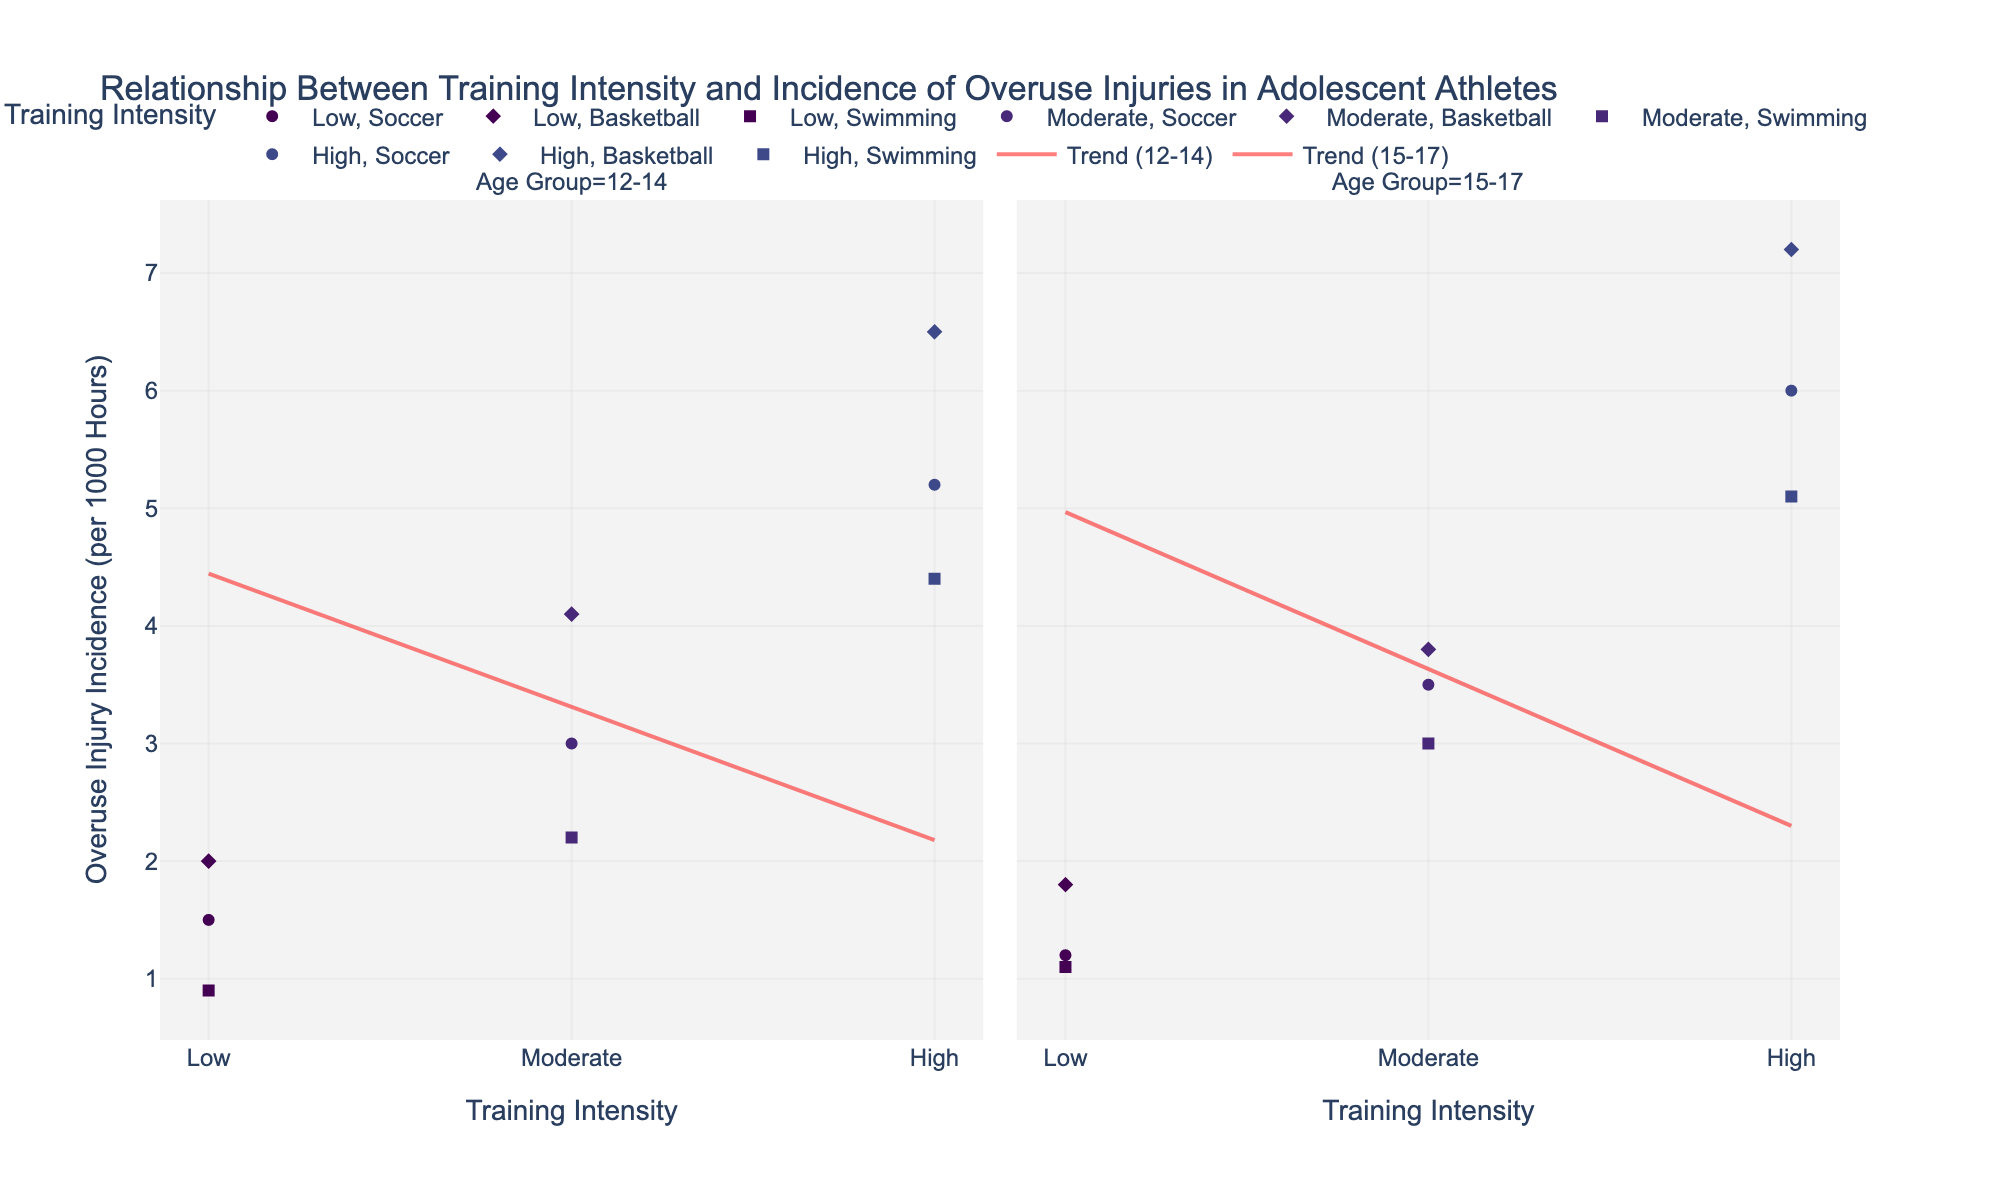What's the title of the figure? The title is usually located at the top of the figure.
Answer: Relationship Between Training Intensity and Incidence of Overuse Injuries in Adolescent Athletes How is training intensity represented in the plot? Training Intensity is shown on the x-axis as categorical variables named Low, Moderate, and High. Additionally, different colors are used to represent each intensity level.
Answer: Through x-axis categories and colors How does the overuse injury incidence change with training intensity for 15-17-year-old swimmers? For 15-17-year-old swimmers, the overuse injury incidence increases as the training intensity goes from Low to Moderate to High. We see 1.1 incidents/1000 hours at Low intensity, 3.0 at Moderate, and 5.1 at High.
Answer: It increases Which sport has the highest overuse injury incidence at High training intensity for the 12-14 age group? Look at the High training intensity markers in the 12-14 age group subplot. Basketball has the highest overuse injury incidence, with 6.5 per 1000 hours.
Answer: Basketball Compare the overuse injury incidence between 12-14 and 15-17 age groups for Soccer at Moderate training intensity. In the plot, the overuse injury incidence for Soccer at Moderate training intensity is 3.0 for the 12-14 age group and 3.5 for the 15-17 age group.
Answer: Higher in 15-17 What is the trend in overuse injury incidence with increasing training intensity for 15-17-year-old basketball players based on the trend line? The trend line for 15-17-year-old basketball players indicates that overuse injury incidence increases linearly as the training intensity increases from Low to High.
Answer: Increasing Is the relationship between training intensity and overuse injury incidence consistent across different sports for the same age group? For both age groups (12-14 and 15-17), across all sports, overuse injury incidence increases with higher training intensity. This consistency is evident from the upward trend lines in each subplot.
Answer: Yes Which age group shows a higher overall trend in overuse injury incidence? Compare the trend lines for both age groups. The 15-17 age group generally shows higher values on the trend line for each sport, indicating a higher overall trend.
Answer: 15-17 Count the total number of data points for each sport shown in the scatter plot. Count each plotted marker representing data points for Soccer, Basketball, and Swimming. Each sport has 6 data points, 3 for each age group at different training intensities.
Answer: 6 for each sport 